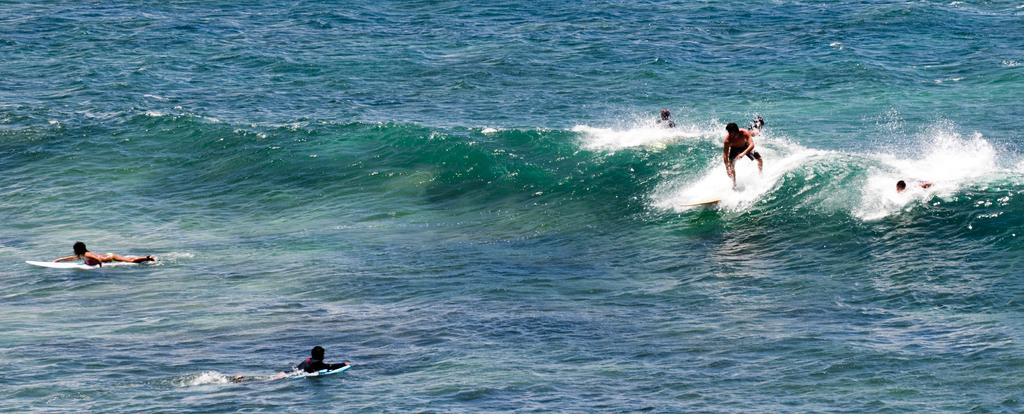How many people are in the group visible in the image? There is a group of people in the image. What activity are the people engaged in? The people are surfing. What equipment are the people using for surfing? The people are using surfboards. Where is the surfing taking place? The surfing is taking place on the water. What type of silk is being woven by the boys in the image? There are no boys or silk present in the image; it features a group of people surfing on the water. What is the hammer being used for in the image? There is no hammer present in the image. 